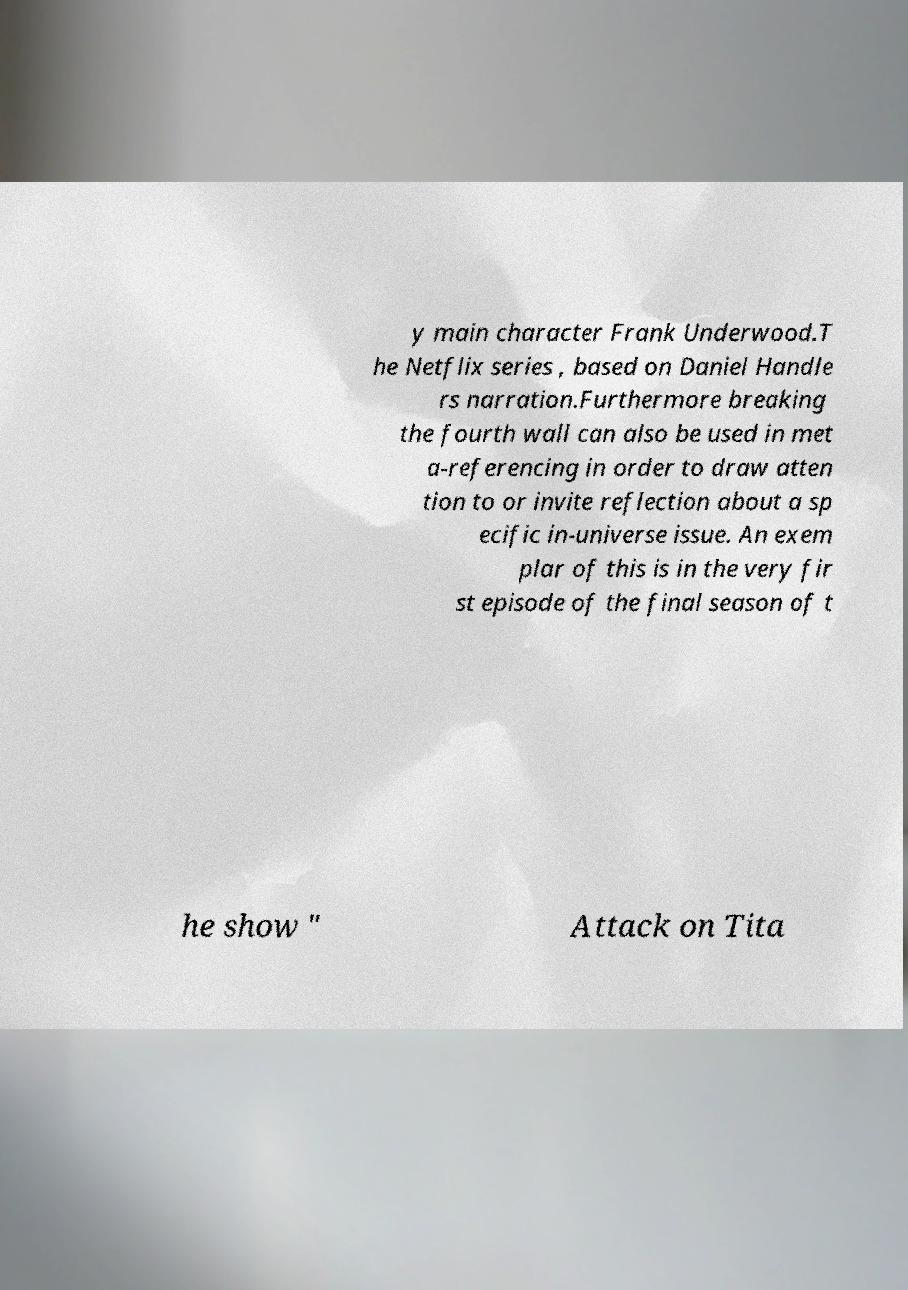Could you extract and type out the text from this image? y main character Frank Underwood.T he Netflix series , based on Daniel Handle rs narration.Furthermore breaking the fourth wall can also be used in met a-referencing in order to draw atten tion to or invite reflection about a sp ecific in-universe issue. An exem plar of this is in the very fir st episode of the final season of t he show " Attack on Tita 